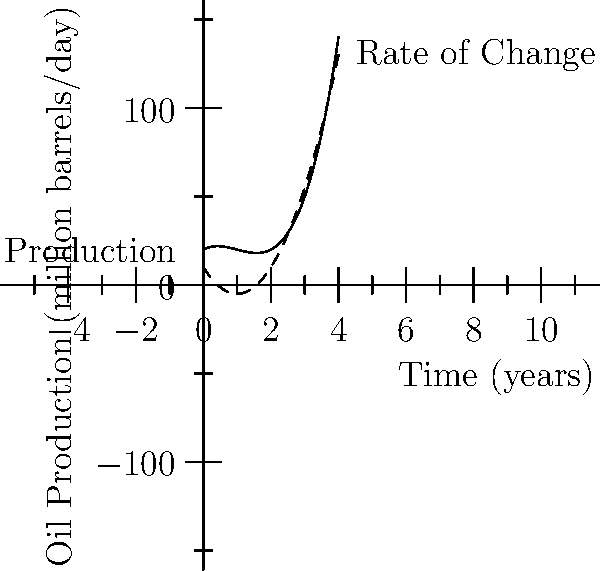The graph shows oil production (solid line) and its rate of change (dashed line) over time. At what point in time does the rate of change in oil production reach its minimum? What policy implications might this have for regulating oil companies? To find the minimum rate of change, we need to analyze the dashed line representing the derivative of the production function.

1. The rate of change (derivative) is represented by the function:
   $$f'(x) = 15x^2 - 30x + 10$$

2. To find the minimum, we need to find where the second derivative equals zero:
   $$f''(x) = 30x - 30 = 0$$

3. Solving for x:
   $$30x - 30 = 0$$
   $$30x = 30$$
   $$x = 1$$

4. We can confirm this is a minimum by checking that $f''(1) > 0$:
   $$f''(1) = 30 > 0$$

5. Therefore, the rate of change reaches its minimum at x = 1 year.

Policy implications:
1. This point represents when oil production growth is slowest.
2. Regulators might use this information to time the implementation of new policies.
3. It could indicate a potential transition point in the industry, suggesting a good time for introducing renewable energy incentives.
4. Stricter regulations might be more palatable to implement when the industry is at its slowest growth rate.
Answer: 1 year; optimal timing for implementing new regulations 